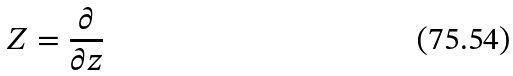<formula> <loc_0><loc_0><loc_500><loc_500>Z = \frac { \partial } { \partial z }</formula> 